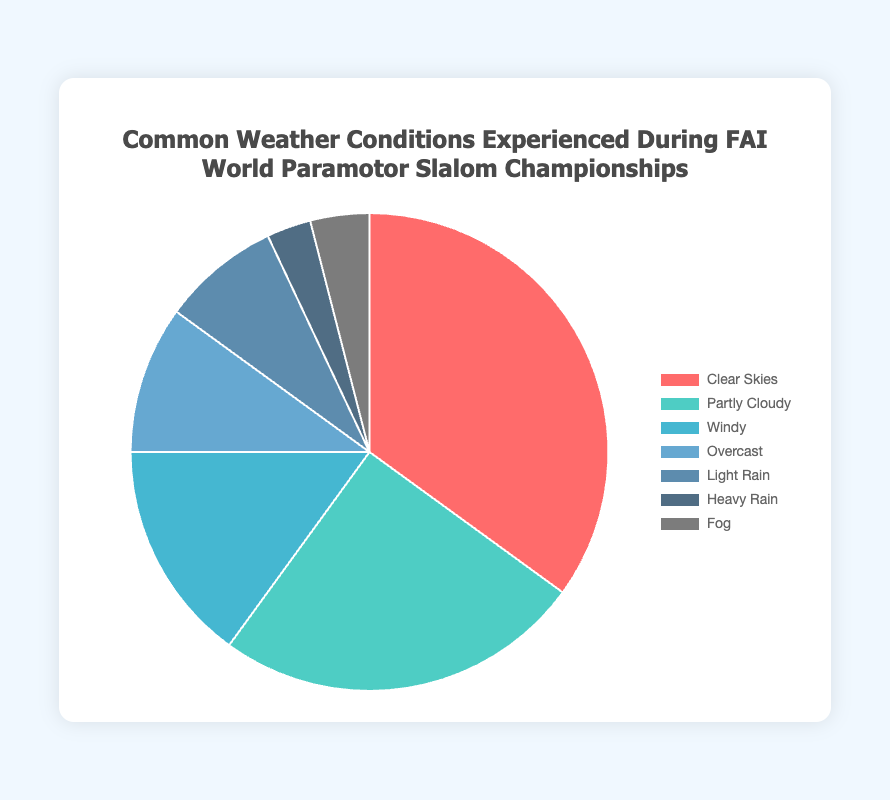Which weather condition is most commonly experienced during FAI World Paramotor Slalom Championships? The largest section of the pie chart is labeled "Clear Skies" with a percentage of 35%.
Answer: Clear Skies How many times more common is "Clear Skies" compared to "Heavy Rain"? Clear Skies has a percentage of 35% while Heavy Rain has a percentage of 3%. The ratio is 35 divided by 3.
Answer: About 11.7 times What is the total percentage of time spent in conditions other than "Clear Skies"? Adding all the percentages except for "Clear Skies" (35%): 25% + 15% + 10% + 8% + 3% + 4% = 65%
Answer: 65% Which weather conditions together represent exactly half of the time experienced during competitions? By adding percentages starting from the largest until reaching 50%, we get 35% (Clear Skies) + 15% (Windy) = 50%.
Answer: Clear Skies and Windy Is "Partly Cloudy" more or less frequent than "Windy"? According to the percentages, Partly Cloudy is 25% and Windy is 15%.
Answer: More frequent What is the three most frequent weather conditions experienced during the championship? The top three largest sections/percentages in the pie chart are Clear Skies (35%), Partly Cloudy (25%), and Windy (15%).
Answer: Clear Skies, Partly Cloudy, Windy How much more common are "Clear Skies" compared to "Overcast"? Clear Skies have a percentage of 35%, and Overcast has 10%. The difference is 35% - 10%.
Answer: 25% more What are the least frequent weather conditions? The smallest sections in the pie chart represent Heavy Rain (3%) and Fog (4%).
Answer: Heavy Rain and Fog What is the combined percentage of "Light Rain" and "Heavy Rain"? Adding the percentages of Light Rain (8%) and Heavy Rain (3%) results in 8% + 3%.
Answer: 11% Which weather condition is represented by the cyan-colored section of the pie chart? The cyan-colored section in the chart corresponds to the "Partly Cloudy" condition.
Answer: Partly Cloudy 